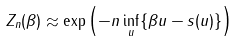<formula> <loc_0><loc_0><loc_500><loc_500>Z _ { n } ( \beta ) \approx \exp \left ( - n \inf _ { u } \{ \beta u - s ( u ) \} \right )</formula> 